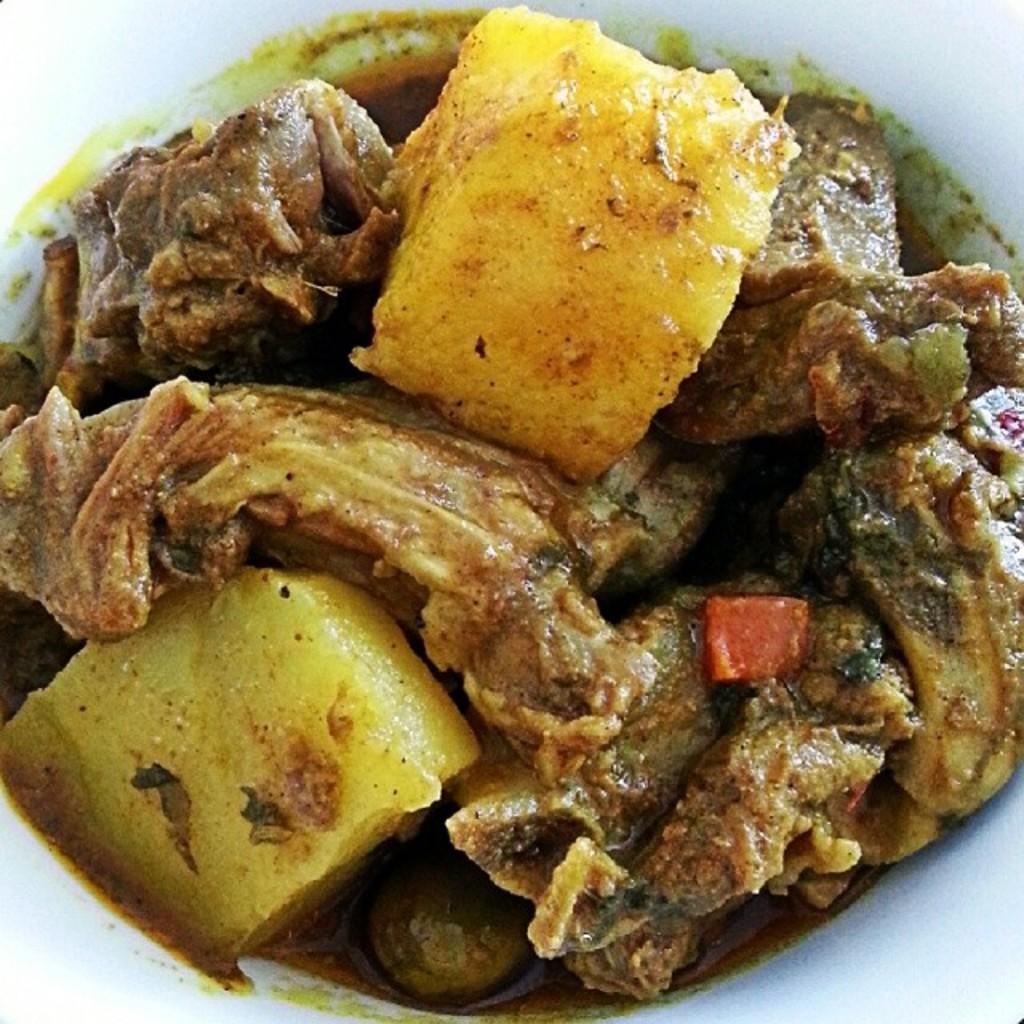Describe this image in one or two sentences. In this picture we can see food. 